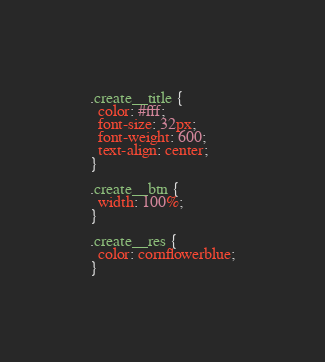<code> <loc_0><loc_0><loc_500><loc_500><_CSS_>.create__title {
  color: #fff;
  font-size: 32px;
  font-weight: 600;
  text-align: center;
}

.create__btn {
  width: 100%;
}

.create__res {
  color: cornflowerblue;
}</code> 